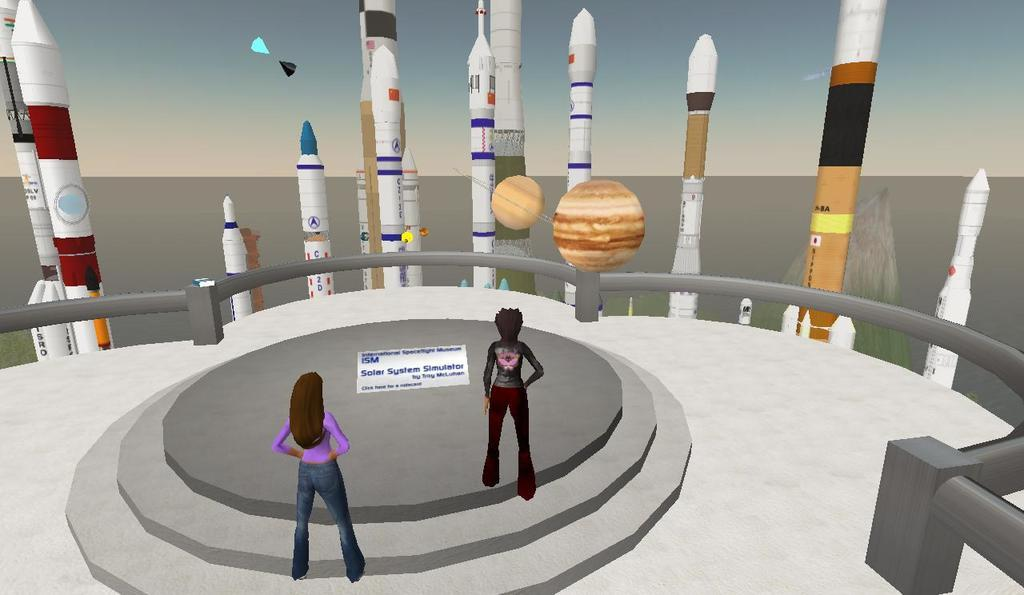What type of characters are present in the image? There are animated people in the image. What vehicles are featured in the image? There are rockets in the image. What other objects can be seen in the image besides the animated people and rockets? There are other objects in the image. What can be seen in the background of the image? The sky is visible in the background of the image. How many kittens are playing with the hour in the image? There are no kittens or hours present in the image. What type of crow can be seen interacting with the rockets in the image? There is no crow present in the image; only animated people and rockets are visible. 